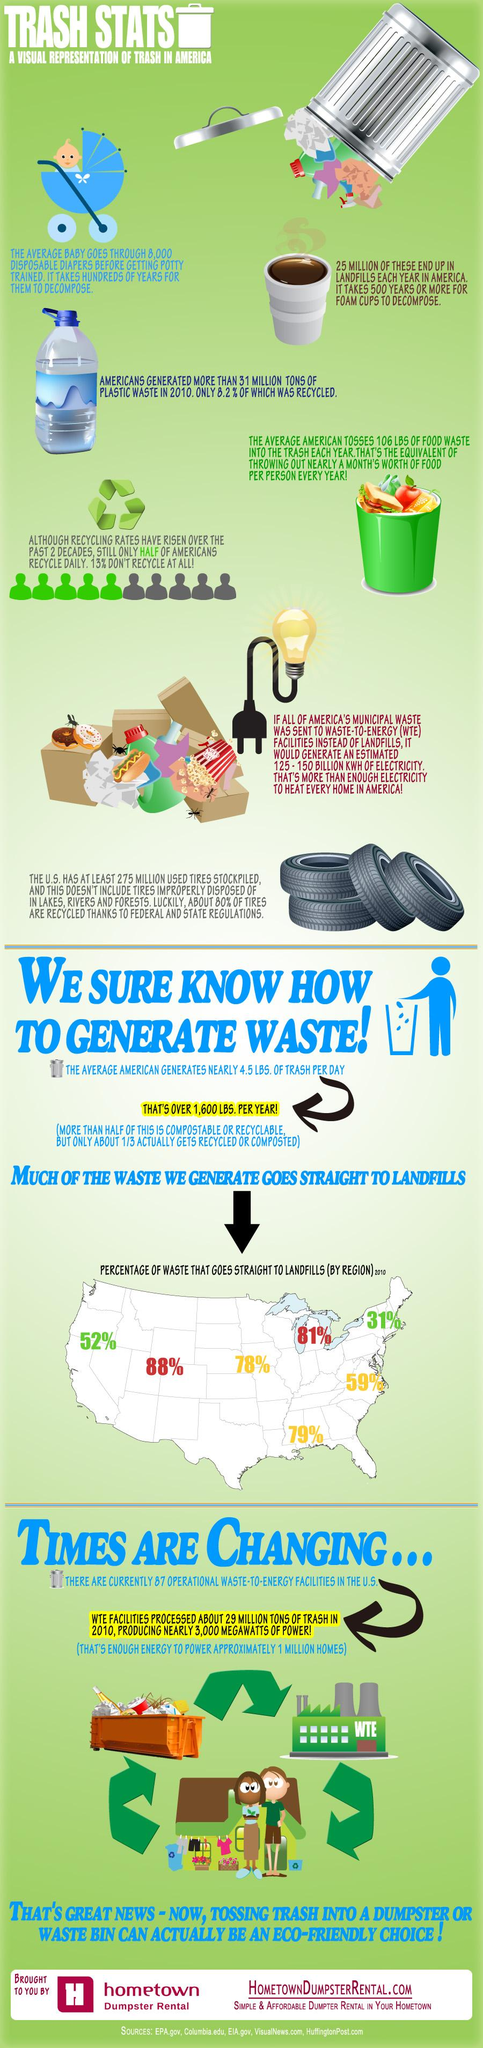List a handful of essential elements in this visual. According to recent estimates, over 25 million foam cups are generated as waste each year. In a year, the American population generates an excess of 1,600 pounds of waste on average. 